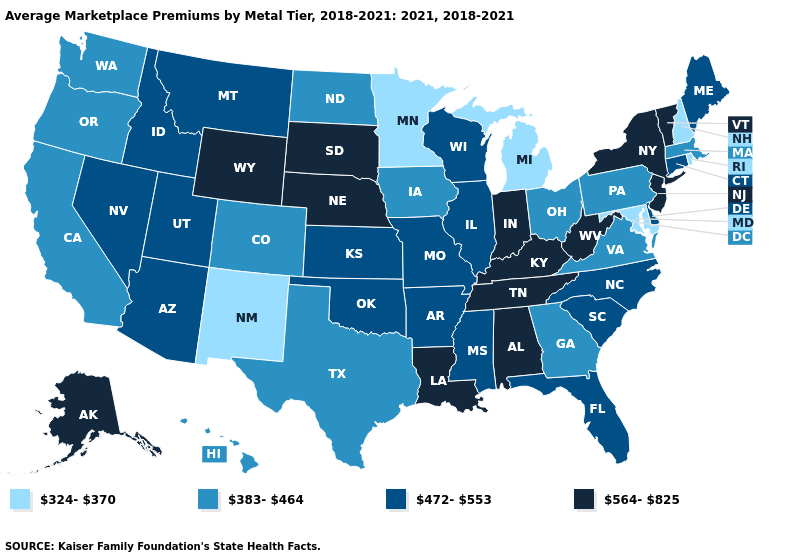Name the states that have a value in the range 383-464?
Short answer required. California, Colorado, Georgia, Hawaii, Iowa, Massachusetts, North Dakota, Ohio, Oregon, Pennsylvania, Texas, Virginia, Washington. Name the states that have a value in the range 324-370?
Concise answer only. Maryland, Michigan, Minnesota, New Hampshire, New Mexico, Rhode Island. What is the value of Idaho?
Quick response, please. 472-553. Among the states that border Connecticut , which have the highest value?
Answer briefly. New York. Does the first symbol in the legend represent the smallest category?
Short answer required. Yes. What is the value of Massachusetts?
Write a very short answer. 383-464. Name the states that have a value in the range 564-825?
Keep it brief. Alabama, Alaska, Indiana, Kentucky, Louisiana, Nebraska, New Jersey, New York, South Dakota, Tennessee, Vermont, West Virginia, Wyoming. Which states have the highest value in the USA?
Quick response, please. Alabama, Alaska, Indiana, Kentucky, Louisiana, Nebraska, New Jersey, New York, South Dakota, Tennessee, Vermont, West Virginia, Wyoming. What is the value of North Carolina?
Answer briefly. 472-553. Name the states that have a value in the range 383-464?
Concise answer only. California, Colorado, Georgia, Hawaii, Iowa, Massachusetts, North Dakota, Ohio, Oregon, Pennsylvania, Texas, Virginia, Washington. Name the states that have a value in the range 472-553?
Quick response, please. Arizona, Arkansas, Connecticut, Delaware, Florida, Idaho, Illinois, Kansas, Maine, Mississippi, Missouri, Montana, Nevada, North Carolina, Oklahoma, South Carolina, Utah, Wisconsin. What is the highest value in the West ?
Short answer required. 564-825. Does Massachusetts have the same value as North Dakota?
Be succinct. Yes. Name the states that have a value in the range 383-464?
Give a very brief answer. California, Colorado, Georgia, Hawaii, Iowa, Massachusetts, North Dakota, Ohio, Oregon, Pennsylvania, Texas, Virginia, Washington. What is the lowest value in states that border Oklahoma?
Short answer required. 324-370. 